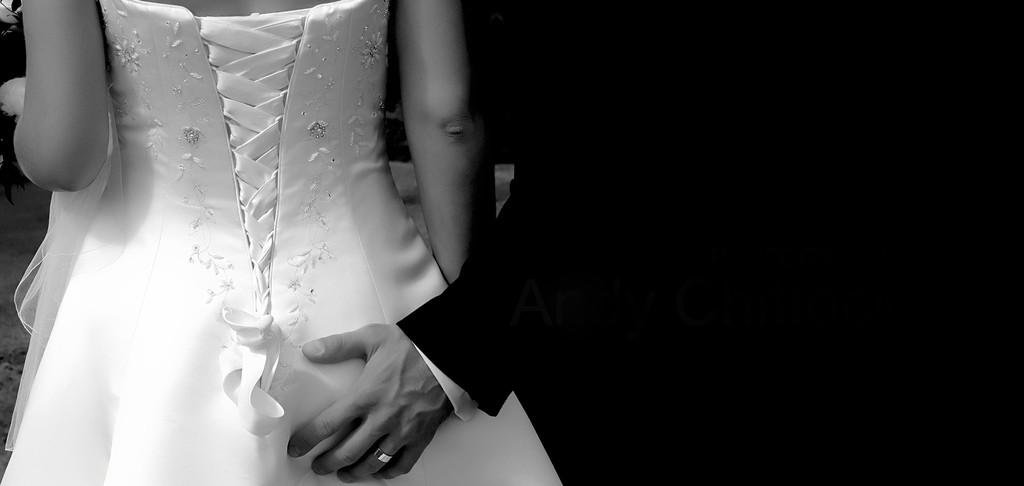How many people are in the image? There are two persons in the image. Can you describe the positioning of the people in the image? The woman is on the left side of the image, and the man is on the right side of the image. What is the woman wearing in the image? The woman is wearing a white dress in the image. What is the man wearing in the image? The man is wearing a black suit in the image. What type of jam can be seen dripping from the icicle in the image? There is no jam or icicle present in the image; it features two people, a woman and a man, dressed in specific attire. 